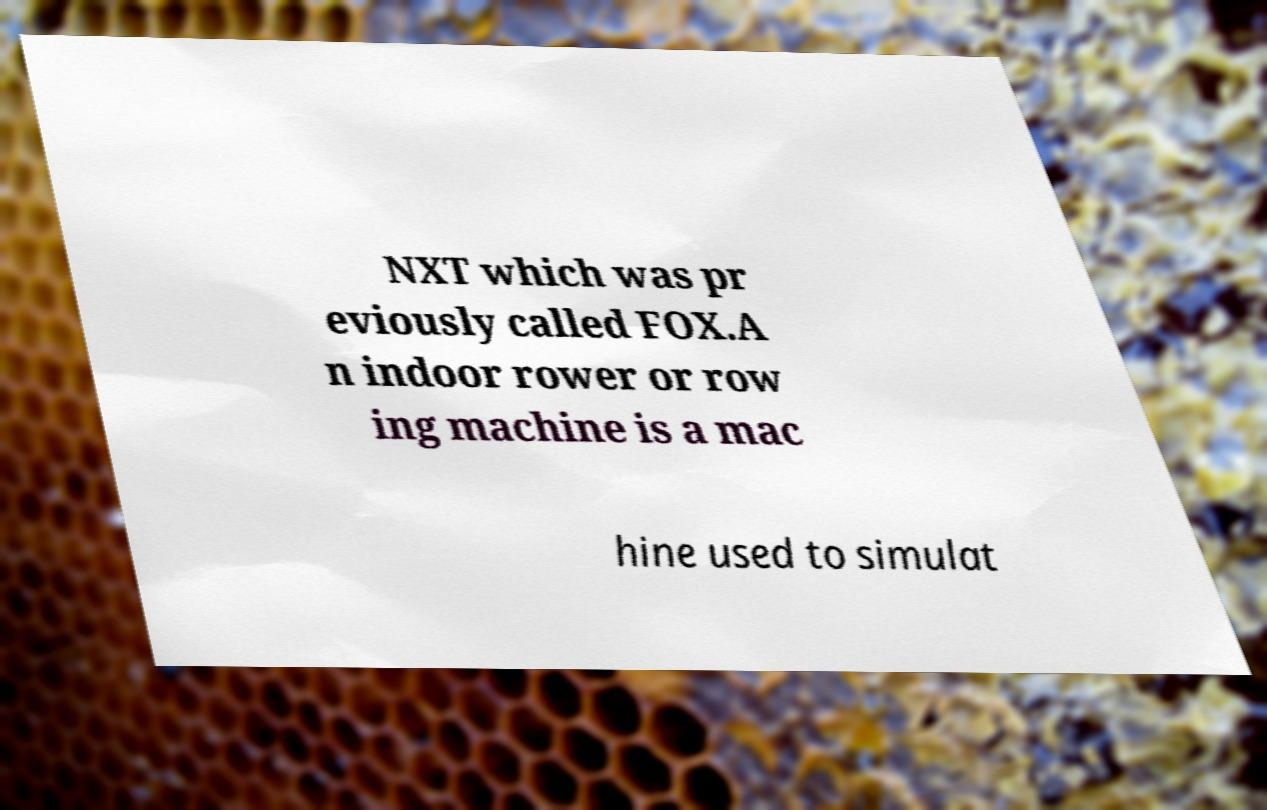There's text embedded in this image that I need extracted. Can you transcribe it verbatim? NXT which was pr eviously called FOX.A n indoor rower or row ing machine is a mac hine used to simulat 